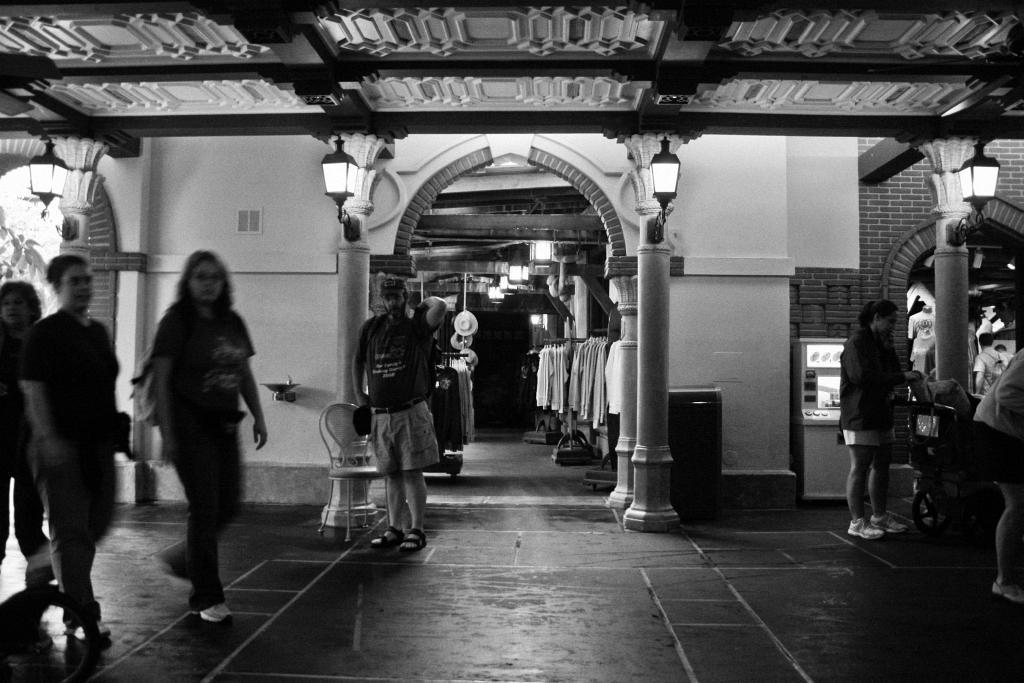Describe this image in one or two sentences. In this image I can see group of people are standing. In the background I can see lights on the pillars. I can also see a wall and some other objects. This picture is black and white in color. 